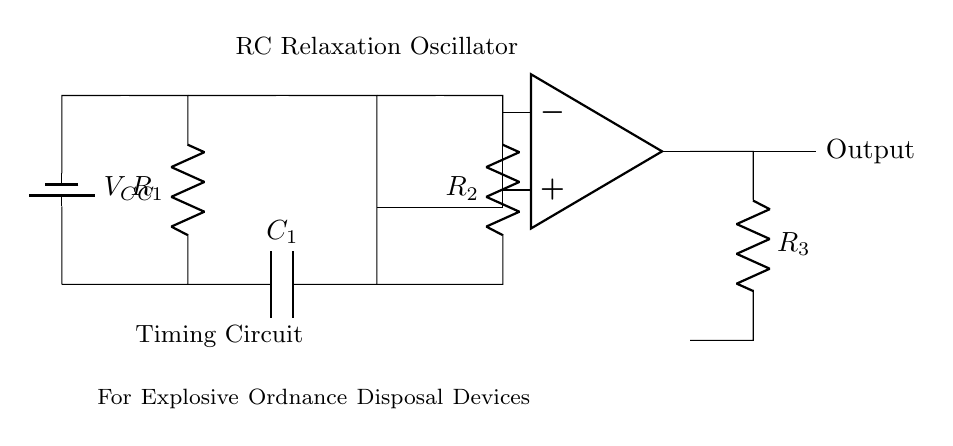What is the value of R1? The diagram does not specify a numerical value for R1, so we cannot determine it from the visual information.
Answer: Not specified Which component provides the timing function? The capacitor labeled C1 is responsible for the timing function in the RC relaxation oscillator by charging and discharging to generate oscillations.
Answer: C1 What type of oscillator is represented in the circuit? The circuit is an RC relaxation oscillator, characterized by the use of resistors and capacitors to produce a non-sinusoidal waveform.
Answer: RC relaxation oscillator How many resistors are in this circuit? The circuit features three resistors, labeled as R1, R2, and R3, which are connected at different points to define the oscillation characteristics.
Answer: Three What is the role of the op-amp in this circuit? The operational amplifier takes the output signal and amplifies it, while also integrating the results of the resistors and capacitor to shape the oscillation profile.
Answer: Amplifier What is the output of this circuit labeled as? The output of the circuit is labeled simply as "Output," indicating the point from which the oscillation signal can be taken for further processing or use.
Answer: Output 